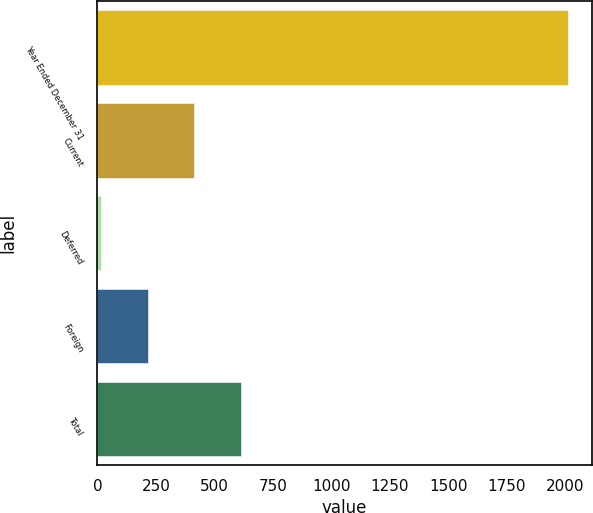<chart> <loc_0><loc_0><loc_500><loc_500><bar_chart><fcel>Year Ended December 31<fcel>Current<fcel>Deferred<fcel>Foreign<fcel>Total<nl><fcel>2013<fcel>414.6<fcel>15<fcel>214.8<fcel>614.4<nl></chart> 